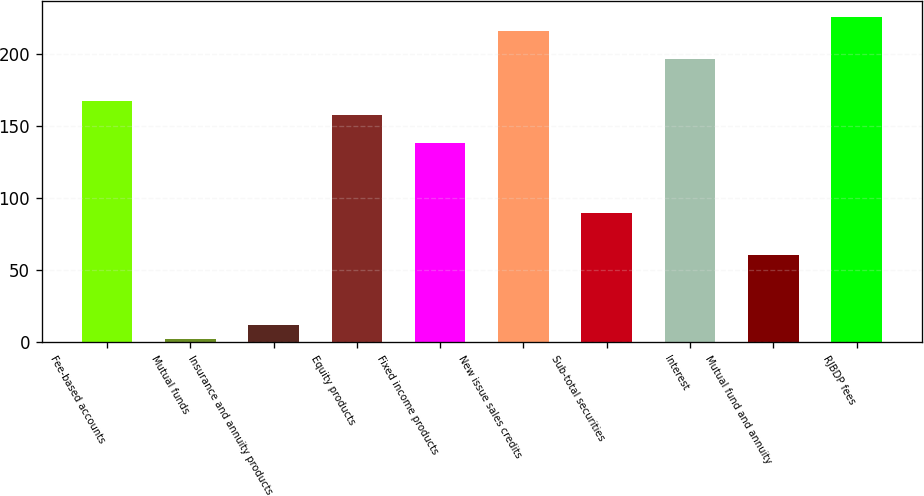<chart> <loc_0><loc_0><loc_500><loc_500><bar_chart><fcel>Fee-based accounts<fcel>Mutual funds<fcel>Insurance and annuity products<fcel>Equity products<fcel>Fixed income products<fcel>New issue sales credits<fcel>Sub-total securities<fcel>Interest<fcel>Mutual fund and annuity<fcel>RJBDP fees<nl><fcel>166.9<fcel>2<fcel>11.7<fcel>157.2<fcel>137.8<fcel>215.4<fcel>89.3<fcel>196<fcel>60.2<fcel>225.1<nl></chart> 